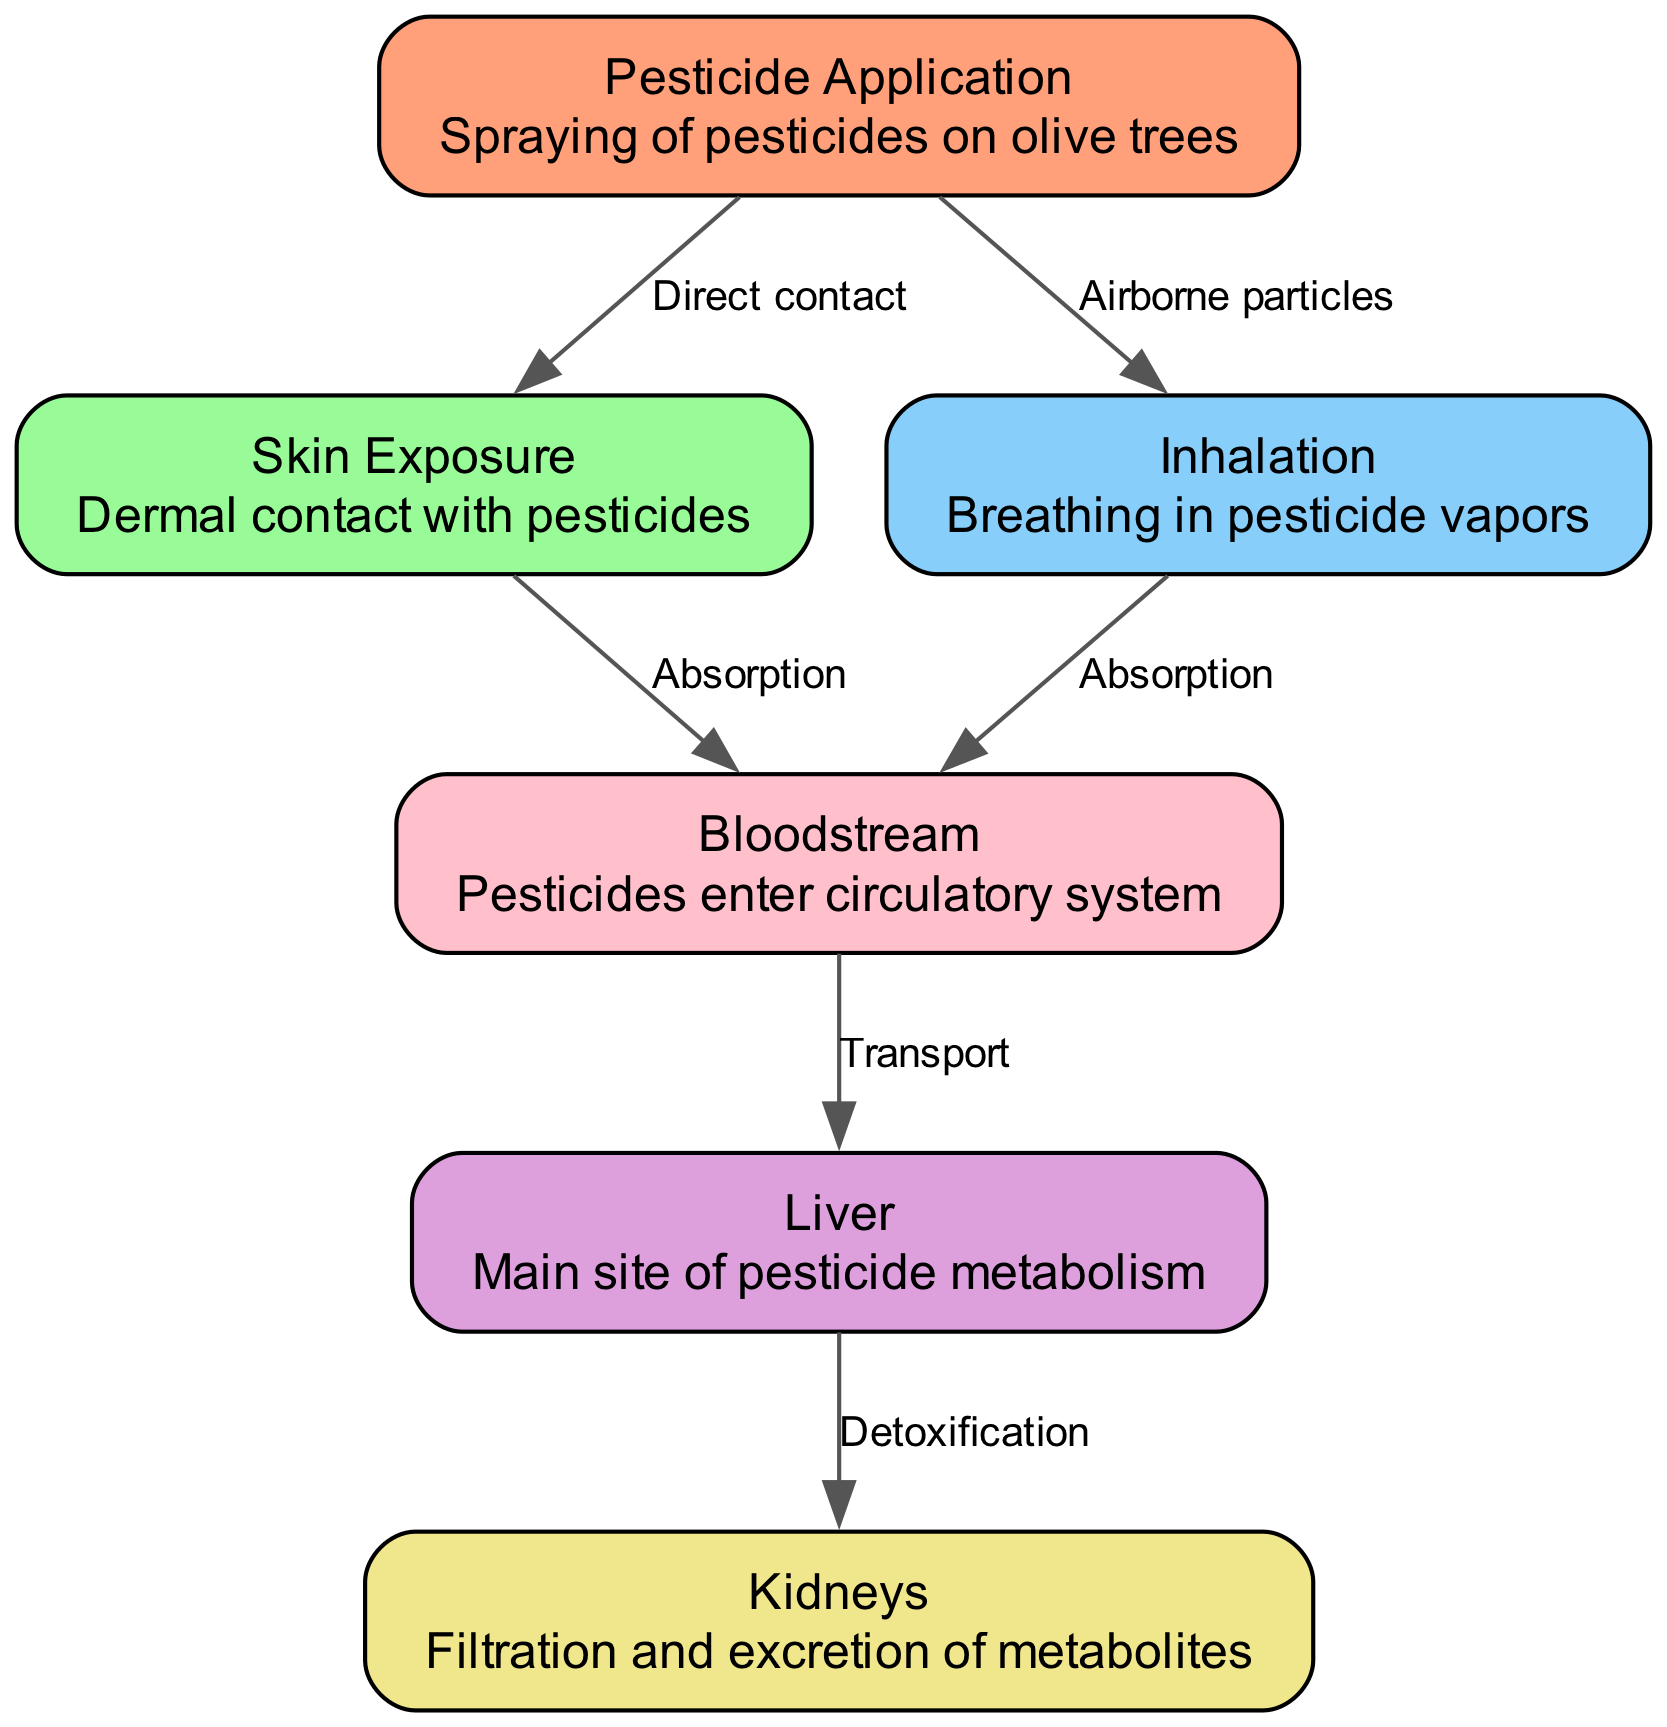What is the first node depicted in the diagram? The first node is labeled "Pesticide Application," which indicates the starting point of the process depicted in the diagram. It's the initial event that leads to subsequent exposures.
Answer: Pesticide Application How many nodes are present in the diagram? By counting the elements listed in the nodes section, we find there are six distinct nodes in the diagram. Each node represents a different aspect of pesticide absorption and metabolism.
Answer: 6 What type of exposure is indicated to lead directly to the bloodstream? The diagram shows that both "Skin Exposure" and "Inhalation" lead directly to the bloodstream through "Absorption." These modes of exposure are critical in understanding how pesticides enter the body.
Answer: Absorption Which organ is identified as the main site of pesticide metabolism? The node labeled "Liver" indicates that it is the primary organ responsible for metabolizing pesticides as presented in the diagram.
Answer: Liver What is the relationship between the "Liver" and the "Kidneys"? The edge labeled "Detoxification" from the "Liver" to the "Kidneys" signifies that once pesticides are metabolized, the substances are then filtered and excreted by the kidneys. This flow of information outlines the detoxification pathway.
Answer: Detoxification Which exposure method is connected with "Airborne particles"? The edge labeled "Airborne particles" connects the "Pesticide Application" node to the "Inhalation" node, indicating that airborne pesticide particles are a method of exposure to farm workers.
Answer: Inhalation What two entry points lead to the bloodstream? The diagram illustrates that "Skin Exposure" and "Inhalation" are two distinct entry points that lead to the bloodstream, showing multiple pathways for pesticide absorption into the body.
Answer: Skin Exposure, Inhalation How does pesticide move from the bloodstream to the liver? The relationship is defined by the "Transport" edge, which shows that once pesticides enter the bloodstream, they are then transported to the liver for metabolism.
Answer: Transport What signifies the flow of pesticides from application to exposure? The directed edges labeled "Direct contact" and "Airborne particles" signify the flow showing how pesticides from the application enter the body through skin contact and inhalation, respectively.
Answer: Direct contact, Airborne particles 